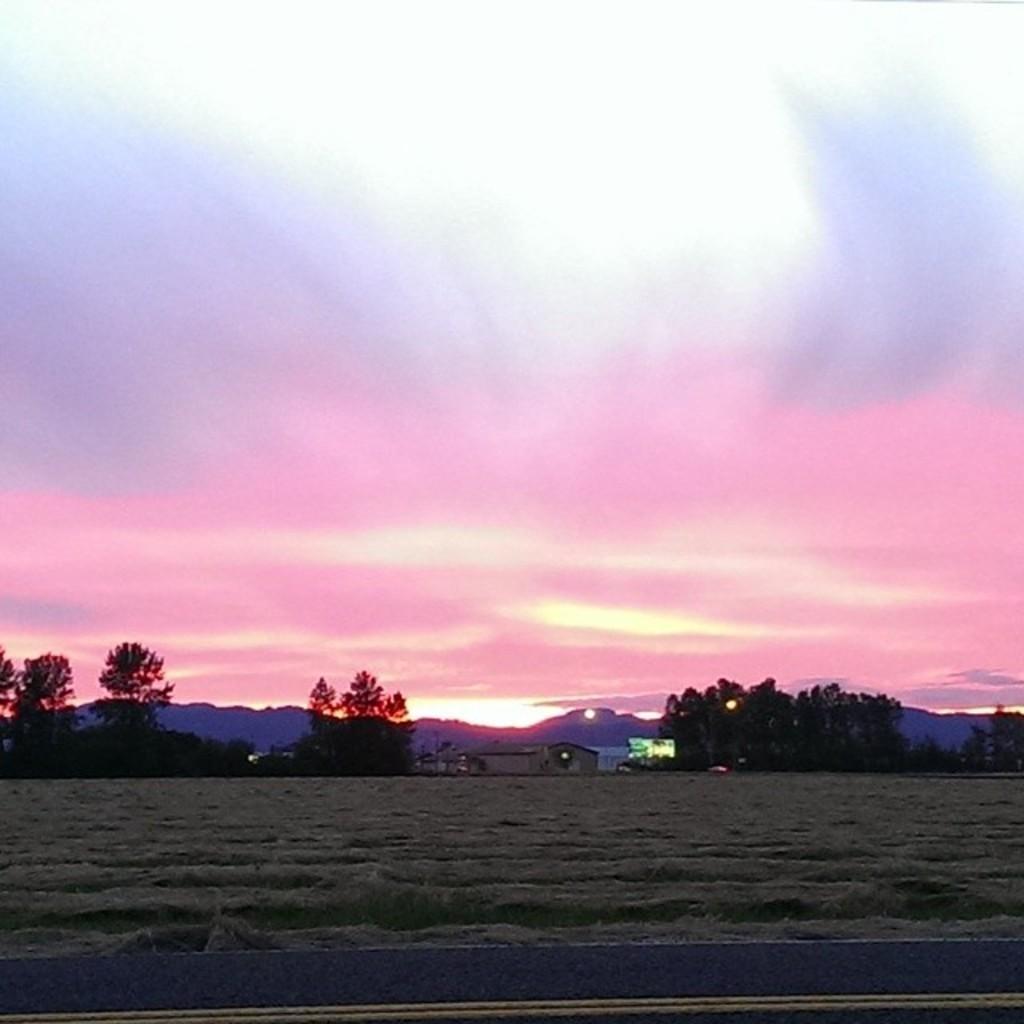How would you summarize this image in a sentence or two? On the bottom we can see road. On the background we can see many trees, advertisement board, building and mountains. On the top we can see sky and clouds. Here we can see the farmland. 